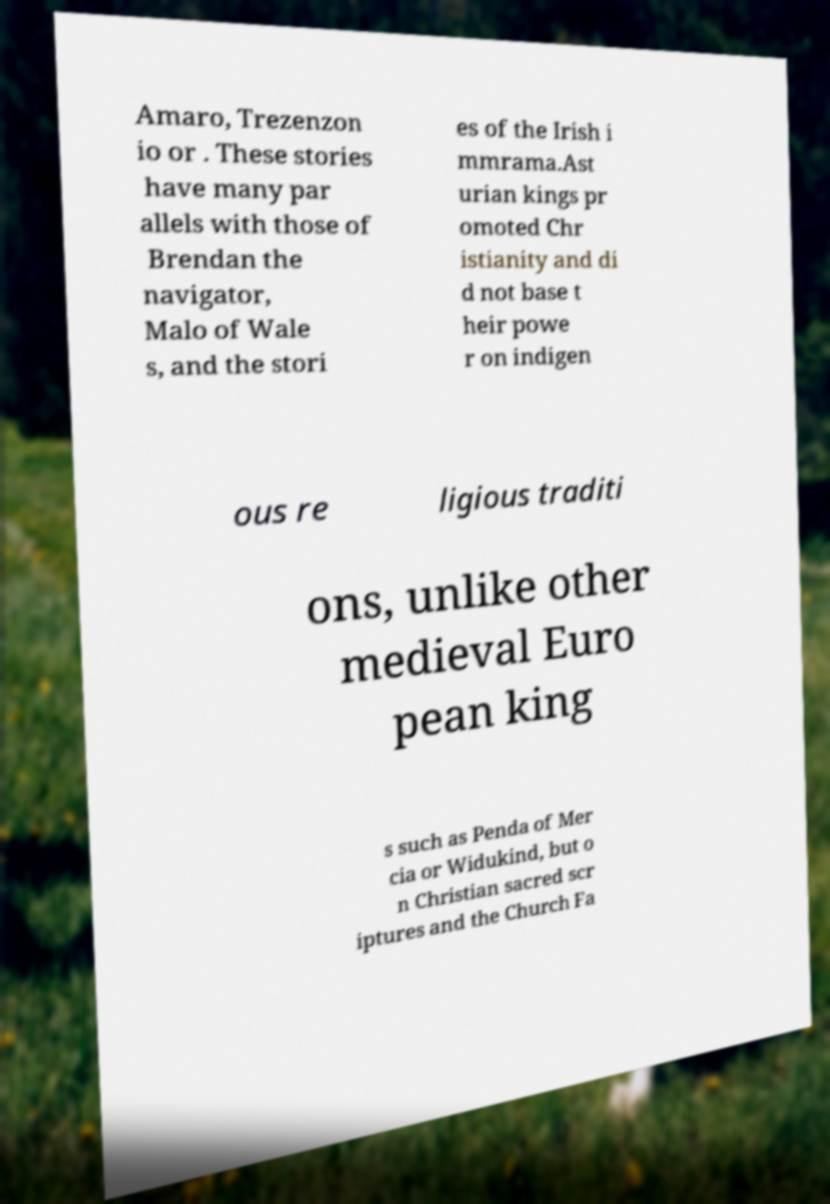Please identify and transcribe the text found in this image. Amaro, Trezenzon io or . These stories have many par allels with those of Brendan the navigator, Malo of Wale s, and the stori es of the Irish i mmrama.Ast urian kings pr omoted Chr istianity and di d not base t heir powe r on indigen ous re ligious traditi ons, unlike other medieval Euro pean king s such as Penda of Mer cia or Widukind, but o n Christian sacred scr iptures and the Church Fa 